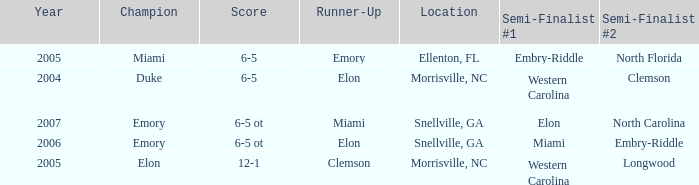When Embry-Riddle made it to the first semi finalist slot, list all the runners up. Emory. Could you parse the entire table? {'header': ['Year', 'Champion', 'Score', 'Runner-Up', 'Location', 'Semi-Finalist #1', 'Semi-Finalist #2'], 'rows': [['2005', 'Miami', '6-5', 'Emory', 'Ellenton, FL', 'Embry-Riddle', 'North Florida'], ['2004', 'Duke', '6-5', 'Elon', 'Morrisville, NC', 'Western Carolina', 'Clemson'], ['2007', 'Emory', '6-5 ot', 'Miami', 'Snellville, GA', 'Elon', 'North Carolina'], ['2006', 'Emory', '6-5 ot', 'Elon', 'Snellville, GA', 'Miami', 'Embry-Riddle'], ['2005', 'Elon', '12-1', 'Clemson', 'Morrisville, NC', 'Western Carolina', 'Longwood']]} 